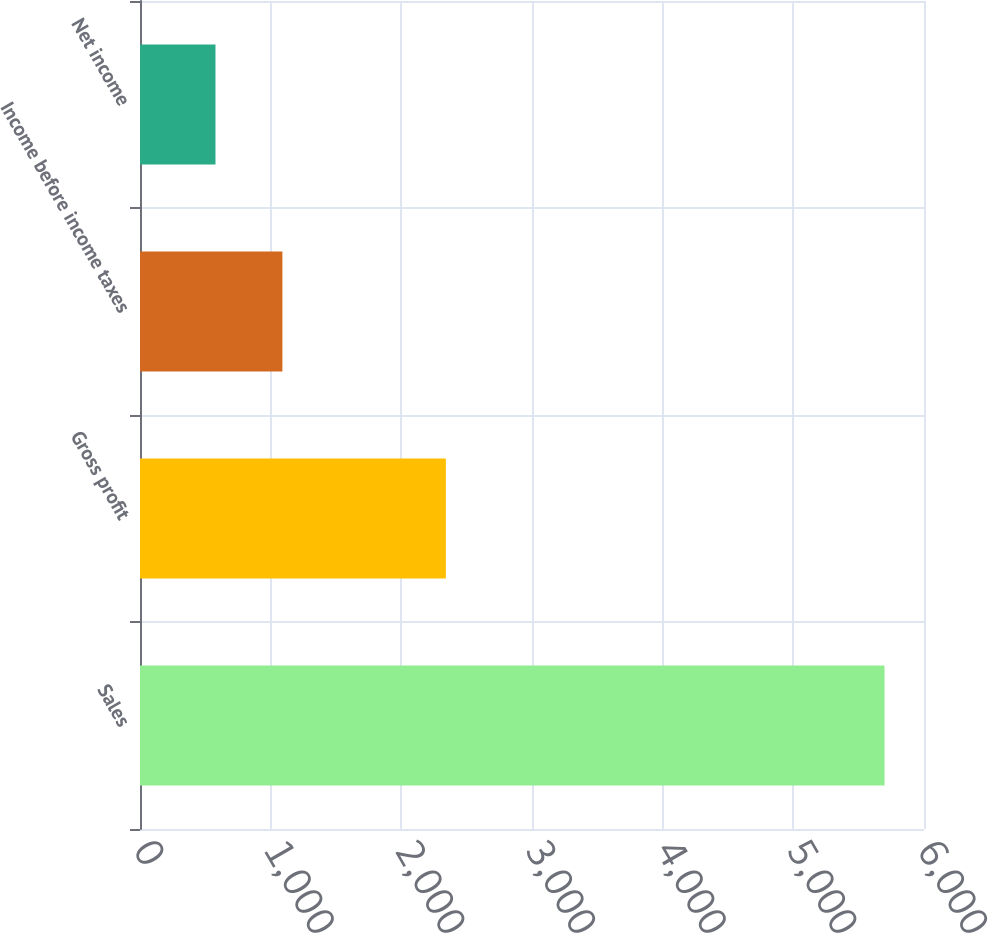<chart> <loc_0><loc_0><loc_500><loc_500><bar_chart><fcel>Sales<fcel>Gross profit<fcel>Income before income taxes<fcel>Net income<nl><fcel>5697.8<fcel>2340.7<fcel>1089.62<fcel>577.6<nl></chart> 